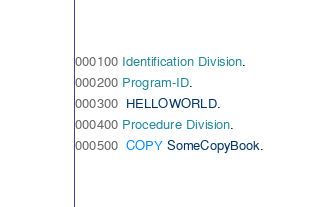Convert code to text. <code><loc_0><loc_0><loc_500><loc_500><_COBOL_>000100 Identification Division.
000200 Program-ID. 
000300  HELLOWORLD.
000400 Procedure Division.
000500  COPY SomeCopyBook.</code> 